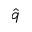<formula> <loc_0><loc_0><loc_500><loc_500>\hat { q }</formula> 